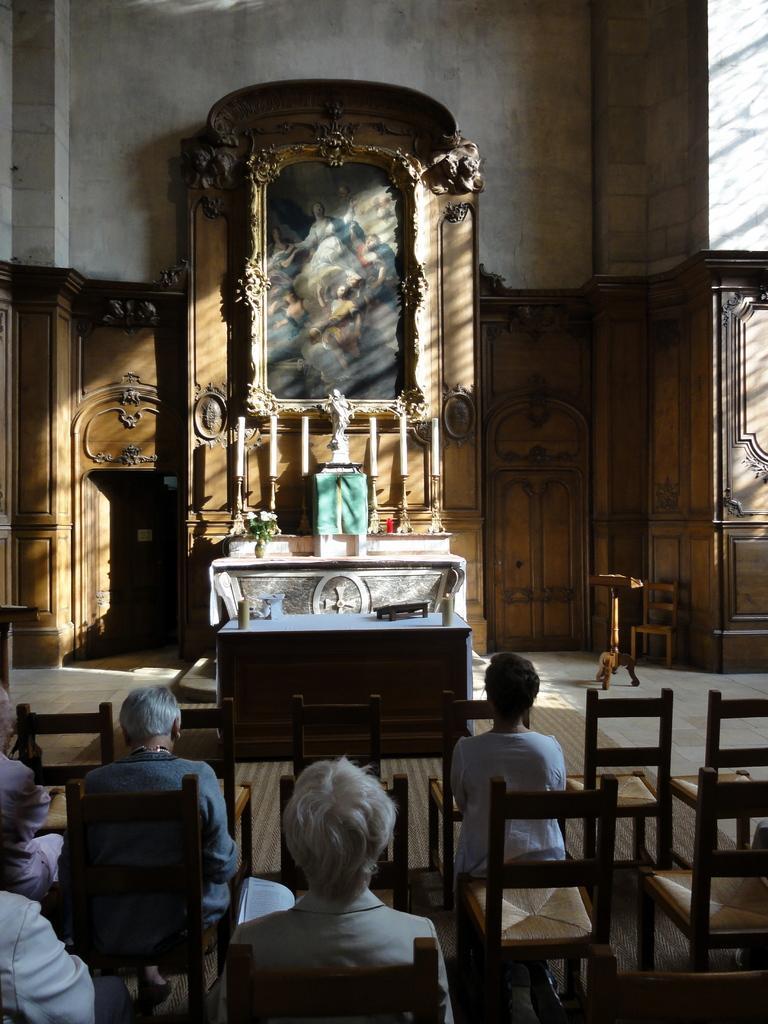Describe this image in one or two sentences. I think this picture is taken in a church, in the bottom there are group of chairs and five people sitting on them. All the people are facing backwards. In the center there is a table, on the table there are two candles. In the background there is a wooden frame and a photo in it. 